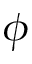Convert formula to latex. <formula><loc_0><loc_0><loc_500><loc_500>\phi</formula> 